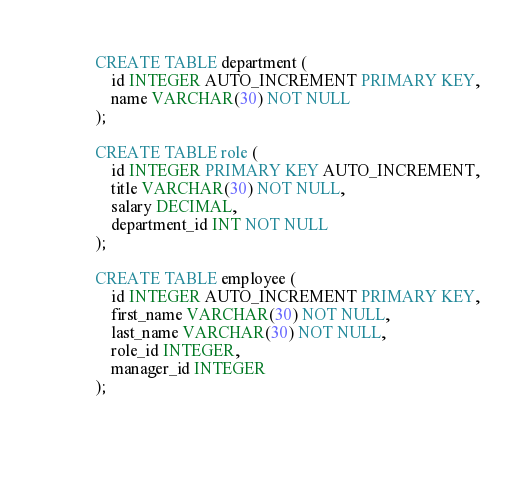<code> <loc_0><loc_0><loc_500><loc_500><_SQL_>CREATE TABLE department (
    id INTEGER AUTO_INCREMENT PRIMARY KEY,
    name VARCHAR(30) NOT NULL
);

CREATE TABLE role (
	id INTEGER PRIMARY KEY AUTO_INCREMENT,
	title VARCHAR(30) NOT NULL,
	salary DECIMAL,
	department_id INT NOT NULL
);

CREATE TABLE employee (
    id INTEGER AUTO_INCREMENT PRIMARY KEY,
    first_name VARCHAR(30) NOT NULL,
    last_name VARCHAR(30) NOT NULL,
    role_id INTEGER,
    manager_id INTEGER   
);


    


</code> 